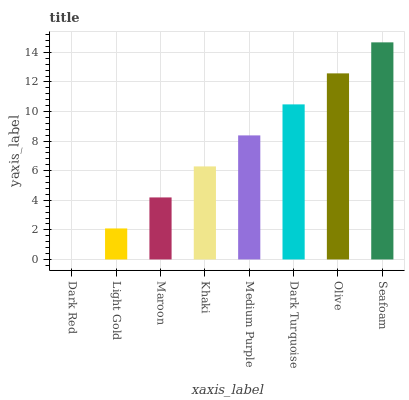Is Dark Red the minimum?
Answer yes or no. Yes. Is Seafoam the maximum?
Answer yes or no. Yes. Is Light Gold the minimum?
Answer yes or no. No. Is Light Gold the maximum?
Answer yes or no. No. Is Light Gold greater than Dark Red?
Answer yes or no. Yes. Is Dark Red less than Light Gold?
Answer yes or no. Yes. Is Dark Red greater than Light Gold?
Answer yes or no. No. Is Light Gold less than Dark Red?
Answer yes or no. No. Is Medium Purple the high median?
Answer yes or no. Yes. Is Khaki the low median?
Answer yes or no. Yes. Is Dark Red the high median?
Answer yes or no. No. Is Dark Turquoise the low median?
Answer yes or no. No. 